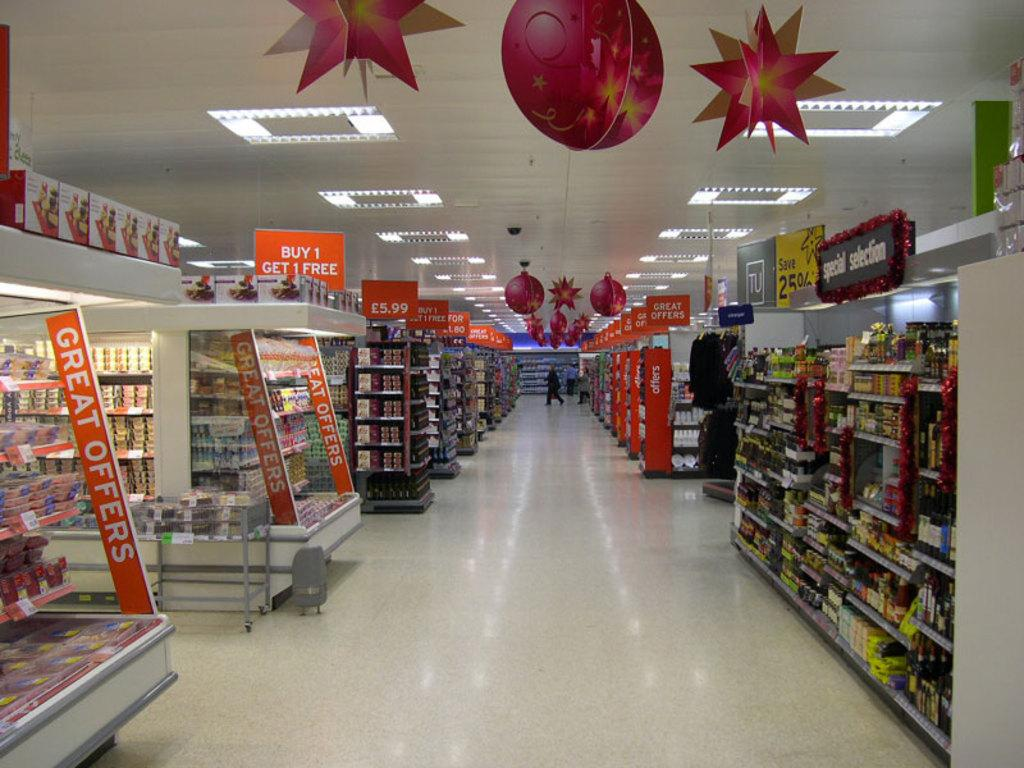<image>
Render a clear and concise summary of the photo. The grocery section of a store that has great offers advertised on the ends of several isles. 